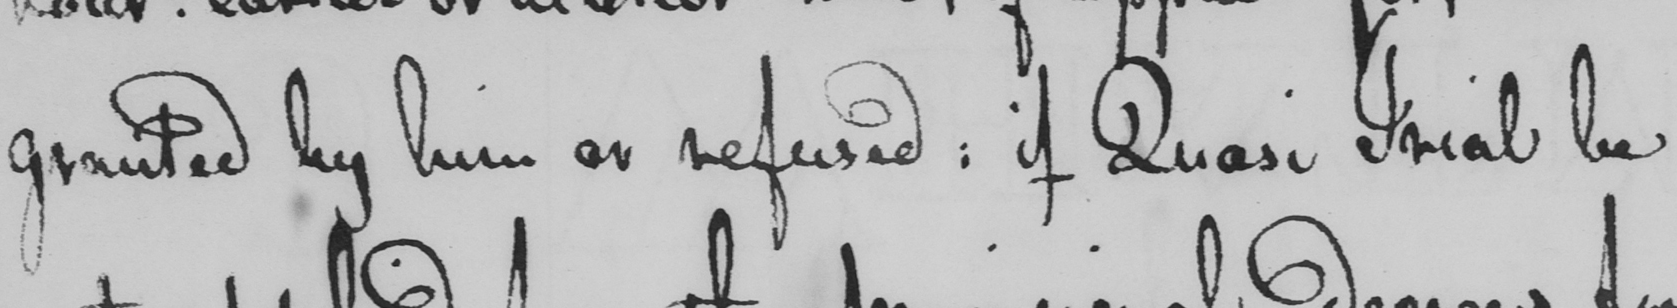Can you read and transcribe this handwriting? granted by him or refused: if Quasi Trial be 